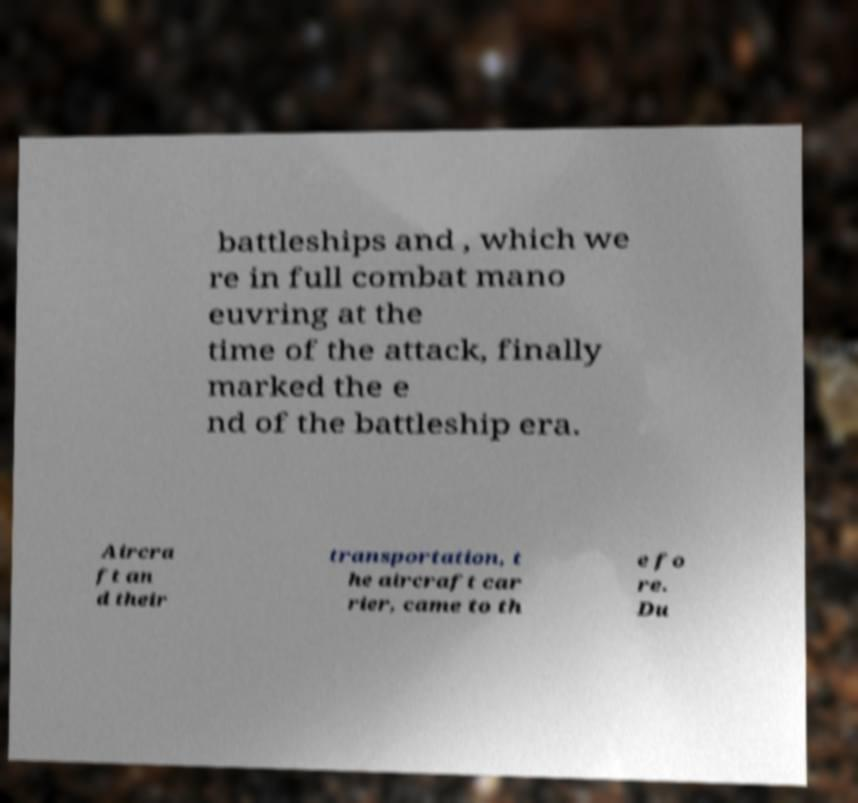Please read and relay the text visible in this image. What does it say? battleships and , which we re in full combat mano euvring at the time of the attack, finally marked the e nd of the battleship era. Aircra ft an d their transportation, t he aircraft car rier, came to th e fo re. Du 